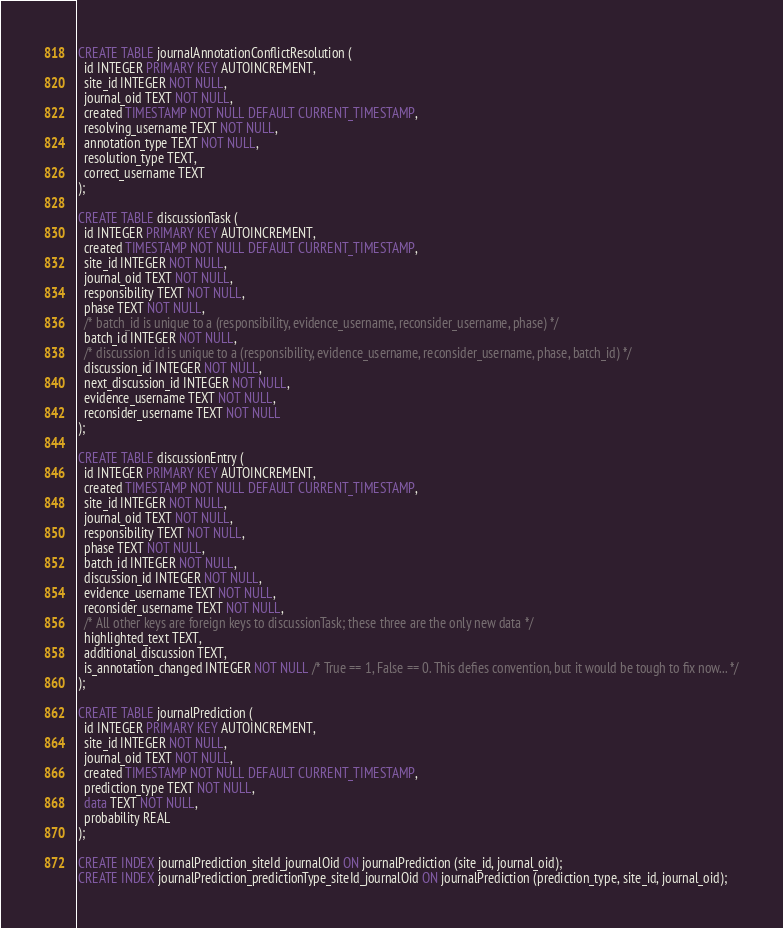Convert code to text. <code><loc_0><loc_0><loc_500><loc_500><_SQL_>
CREATE TABLE journalAnnotationConflictResolution (
  id INTEGER PRIMARY KEY AUTOINCREMENT,
  site_id INTEGER NOT NULL,
  journal_oid TEXT NOT NULL,
  created TIMESTAMP NOT NULL DEFAULT CURRENT_TIMESTAMP,
  resolving_username TEXT NOT NULL,
  annotation_type TEXT NOT NULL,
  resolution_type TEXT,
  correct_username TEXT
);

CREATE TABLE discussionTask (
  id INTEGER PRIMARY KEY AUTOINCREMENT,
  created TIMESTAMP NOT NULL DEFAULT CURRENT_TIMESTAMP,
  site_id INTEGER NOT NULL,
  journal_oid TEXT NOT NULL,
  responsibility TEXT NOT NULL,
  phase TEXT NOT NULL,
  /* batch_id is unique to a (responsibility, evidence_username, reconsider_username, phase) */
  batch_id INTEGER NOT NULL,
  /* discussion_id is unique to a (responsibility, evidence_username, reconsider_username, phase, batch_id) */
  discussion_id INTEGER NOT NULL,
  next_discussion_id INTEGER NOT NULL,
  evidence_username TEXT NOT NULL,
  reconsider_username TEXT NOT NULL
);

CREATE TABLE discussionEntry (
  id INTEGER PRIMARY KEY AUTOINCREMENT,
  created TIMESTAMP NOT NULL DEFAULT CURRENT_TIMESTAMP,
  site_id INTEGER NOT NULL,
  journal_oid TEXT NOT NULL,
  responsibility TEXT NOT NULL,
  phase TEXT NOT NULL,
  batch_id INTEGER NOT NULL,
  discussion_id INTEGER NOT NULL,
  evidence_username TEXT NOT NULL,
  reconsider_username TEXT NOT NULL,
  /* All other keys are foreign keys to discussionTask; these three are the only new data */
  highlighted_text TEXT,
  additional_discussion TEXT,
  is_annotation_changed INTEGER NOT NULL /* True == 1, False == 0. This defies convention, but it would be tough to fix now... */
);

CREATE TABLE journalPrediction (
  id INTEGER PRIMARY KEY AUTOINCREMENT,
  site_id INTEGER NOT NULL,
  journal_oid TEXT NOT NULL,
  created TIMESTAMP NOT NULL DEFAULT CURRENT_TIMESTAMP,
  prediction_type TEXT NOT NULL,
  data TEXT NOT NULL,
  probability REAL
);

CREATE INDEX journalPrediction_siteId_journalOid ON journalPrediction (site_id, journal_oid);
CREATE INDEX journalPrediction_predictionType_siteId_journalOid ON journalPrediction (prediction_type, site_id, journal_oid);

</code> 